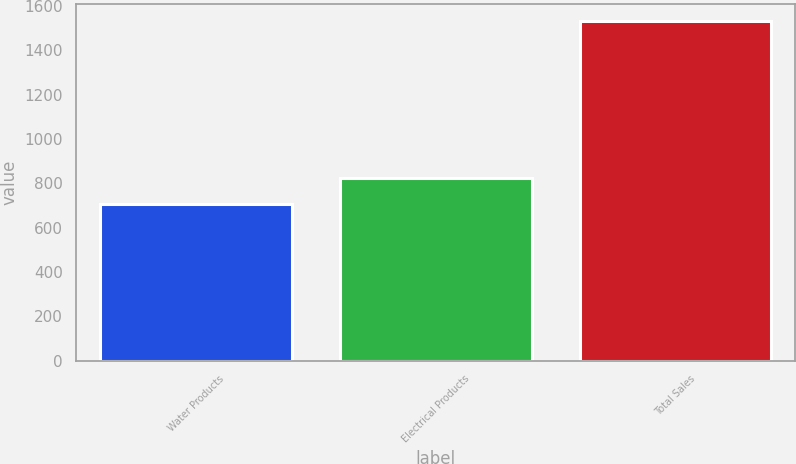Convert chart to OTSL. <chart><loc_0><loc_0><loc_500><loc_500><bar_chart><fcel>Water Products<fcel>Electrical Products<fcel>Total Sales<nl><fcel>706.1<fcel>824.6<fcel>1530.7<nl></chart> 